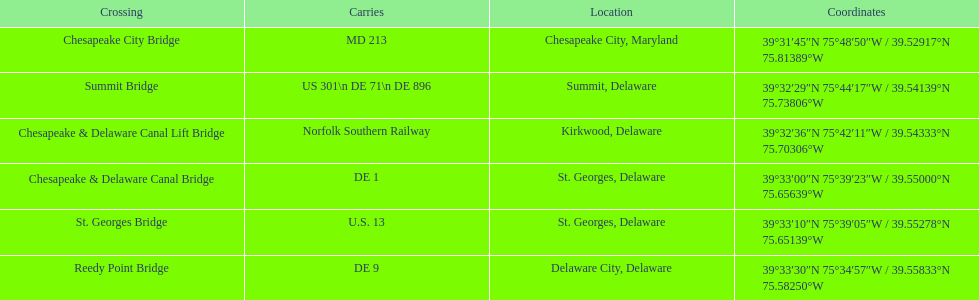I'm looking to parse the entire table for insights. Could you assist me with that? {'header': ['Crossing', 'Carries', 'Location', 'Coordinates'], 'rows': [['Chesapeake City Bridge', 'MD 213', 'Chesapeake City, Maryland', '39°31′45″N 75°48′50″W\ufeff / \ufeff39.52917°N 75.81389°W'], ['Summit Bridge', 'US 301\\n DE 71\\n DE 896', 'Summit, Delaware', '39°32′29″N 75°44′17″W\ufeff / \ufeff39.54139°N 75.73806°W'], ['Chesapeake & Delaware Canal Lift Bridge', 'Norfolk Southern Railway', 'Kirkwood, Delaware', '39°32′36″N 75°42′11″W\ufeff / \ufeff39.54333°N 75.70306°W'], ['Chesapeake & Delaware Canal Bridge', 'DE 1', 'St.\xa0Georges, Delaware', '39°33′00″N 75°39′23″W\ufeff / \ufeff39.55000°N 75.65639°W'], ['St.\xa0Georges Bridge', 'U.S.\xa013', 'St.\xa0Georges, Delaware', '39°33′10″N 75°39′05″W\ufeff / \ufeff39.55278°N 75.65139°W'], ['Reedy Point Bridge', 'DE\xa09', 'Delaware City, Delaware', '39°33′30″N 75°34′57″W\ufeff / \ufeff39.55833°N 75.58250°W']]} Which bridge is in delaware and carries de 9? Reedy Point Bridge. 